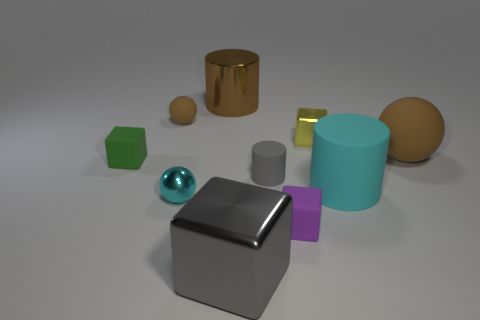There is another ball that is the same color as the large sphere; what is it made of?
Your answer should be very brief. Rubber. Is there a tiny matte thing that has the same color as the large shiny cube?
Provide a succinct answer. Yes. There is a big cube; is its color the same as the rubber cylinder that is left of the purple object?
Make the answer very short. Yes. There is a cylinder on the right side of the purple block; is its color the same as the small shiny ball?
Keep it short and to the point. Yes. What shape is the matte thing that is the same color as the large cube?
Provide a succinct answer. Cylinder. How many tiny gray things are made of the same material as the tiny brown thing?
Give a very brief answer. 1. What material is the cylinder behind the tiny green cube behind the large rubber object in front of the big brown matte object?
Your answer should be compact. Metal. There is a metallic object that is behind the brown rubber sphere that is left of the metallic sphere; what color is it?
Provide a succinct answer. Brown. What is the color of the cylinder that is the same size as the yellow metallic thing?
Ensure brevity in your answer.  Gray. What number of tiny things are either cyan rubber objects or blue matte objects?
Your response must be concise. 0. 